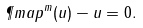Convert formula to latex. <formula><loc_0><loc_0><loc_500><loc_500>\P m a p ^ { m } ( u ) - u = 0 .</formula> 